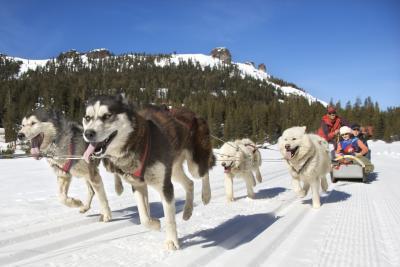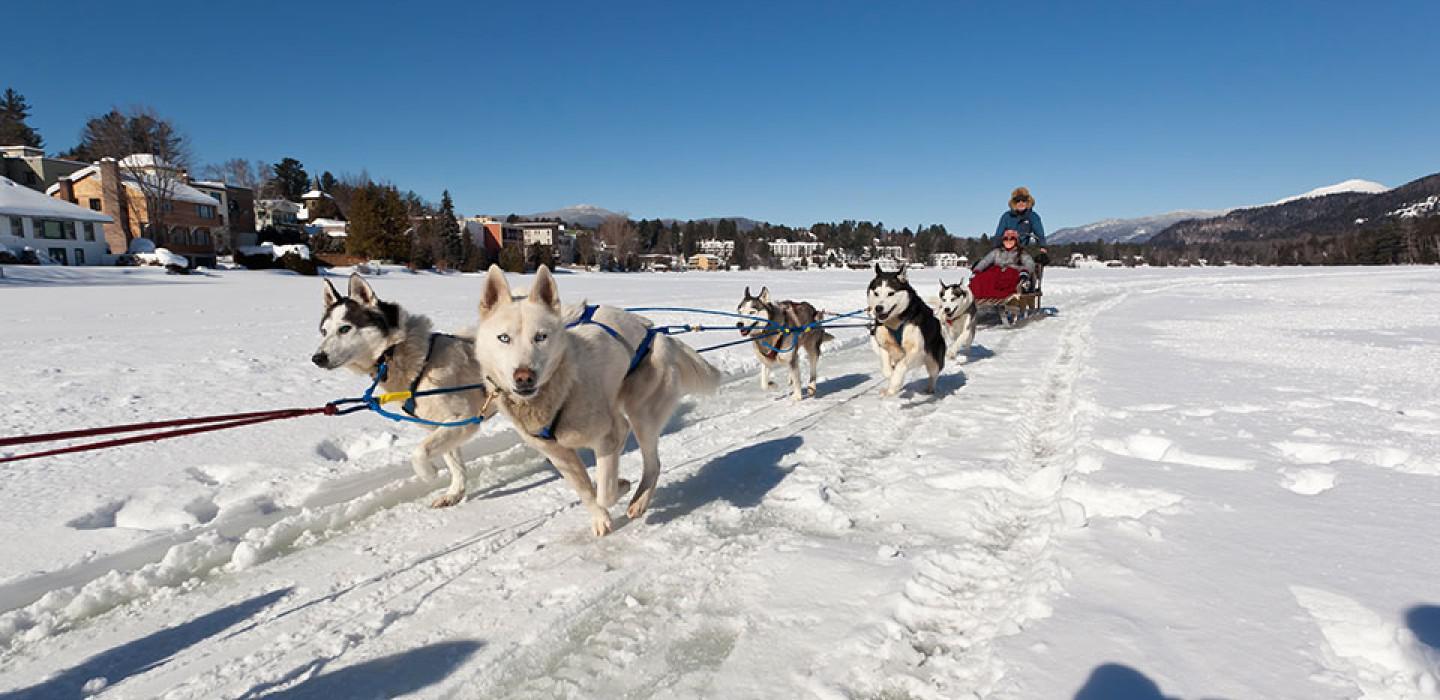The first image is the image on the left, the second image is the image on the right. Given the left and right images, does the statement "There is a person in a red coat in the image on the left" hold true? Answer yes or no. Yes. 